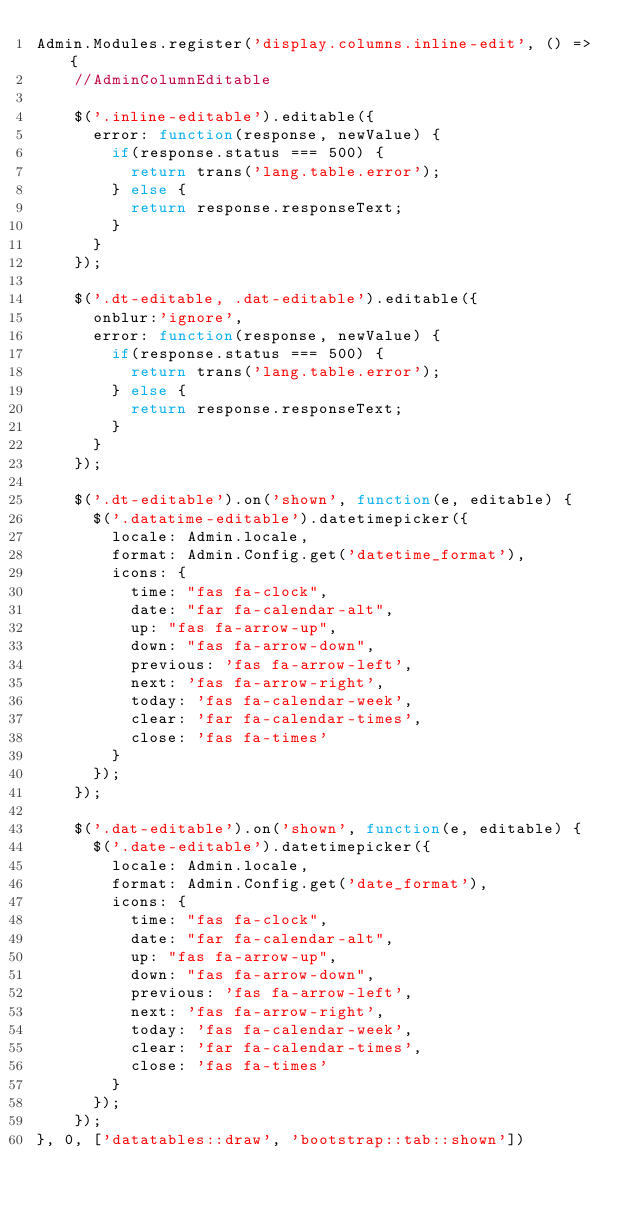Convert code to text. <code><loc_0><loc_0><loc_500><loc_500><_JavaScript_>Admin.Modules.register('display.columns.inline-edit', () => {
    //AdminColumnEditable

    $('.inline-editable').editable({
      error: function(response, newValue) {
        if(response.status === 500) {
          return trans('lang.table.error');
        } else {
          return response.responseText;
        }
      }
    });

    $('.dt-editable, .dat-editable').editable({
      onblur:'ignore',
      error: function(response, newValue) {
        if(response.status === 500) {
          return trans('lang.table.error');
        } else {
          return response.responseText;
        }
      }
    });

    $('.dt-editable').on('shown', function(e, editable) {
      $('.datatime-editable').datetimepicker({
        locale: Admin.locale,
        format: Admin.Config.get('datetime_format'),
        icons: {
          time: "fas fa-clock",
          date: "far fa-calendar-alt",
          up: "fas fa-arrow-up",
          down: "fas fa-arrow-down",
          previous: 'fas fa-arrow-left',
          next: 'fas fa-arrow-right',
          today: 'fas fa-calendar-week',
          clear: 'far fa-calendar-times',
          close: 'fas fa-times'
        }
      });
    });

    $('.dat-editable').on('shown', function(e, editable) {
      $('.date-editable').datetimepicker({
        locale: Admin.locale,
        format: Admin.Config.get('date_format'),
        icons: {
          time: "fas fa-clock",
          date: "far fa-calendar-alt",
          up: "fas fa-arrow-up",
          down: "fas fa-arrow-down",
          previous: 'fas fa-arrow-left',
          next: 'fas fa-arrow-right',
          today: 'fas fa-calendar-week',
          clear: 'far fa-calendar-times',
          close: 'fas fa-times'
        }
      });
    });
}, 0, ['datatables::draw', 'bootstrap::tab::shown'])
</code> 